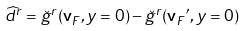<formula> <loc_0><loc_0><loc_500><loc_500>\widehat { d } ^ { r } = \breve { g } ^ { r } ( { \mathbf v } _ { F } , y = 0 ) - \breve { g } ^ { r } ( { { \mathbf v } _ { F } } ^ { \prime } , y = 0 )</formula> 